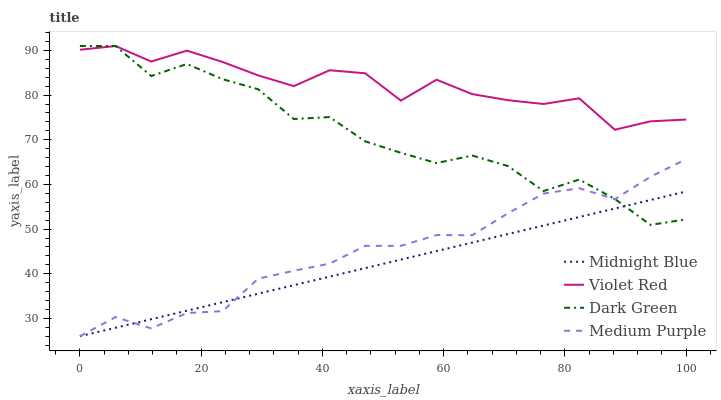Does Midnight Blue have the minimum area under the curve?
Answer yes or no. Yes. Does Violet Red have the maximum area under the curve?
Answer yes or no. Yes. Does Violet Red have the minimum area under the curve?
Answer yes or no. No. Does Midnight Blue have the maximum area under the curve?
Answer yes or no. No. Is Midnight Blue the smoothest?
Answer yes or no. Yes. Is Dark Green the roughest?
Answer yes or no. Yes. Is Violet Red the smoothest?
Answer yes or no. No. Is Violet Red the roughest?
Answer yes or no. No. Does Medium Purple have the lowest value?
Answer yes or no. Yes. Does Violet Red have the lowest value?
Answer yes or no. No. Does Dark Green have the highest value?
Answer yes or no. Yes. Does Midnight Blue have the highest value?
Answer yes or no. No. Is Midnight Blue less than Violet Red?
Answer yes or no. Yes. Is Violet Red greater than Medium Purple?
Answer yes or no. Yes. Does Dark Green intersect Midnight Blue?
Answer yes or no. Yes. Is Dark Green less than Midnight Blue?
Answer yes or no. No. Is Dark Green greater than Midnight Blue?
Answer yes or no. No. Does Midnight Blue intersect Violet Red?
Answer yes or no. No. 